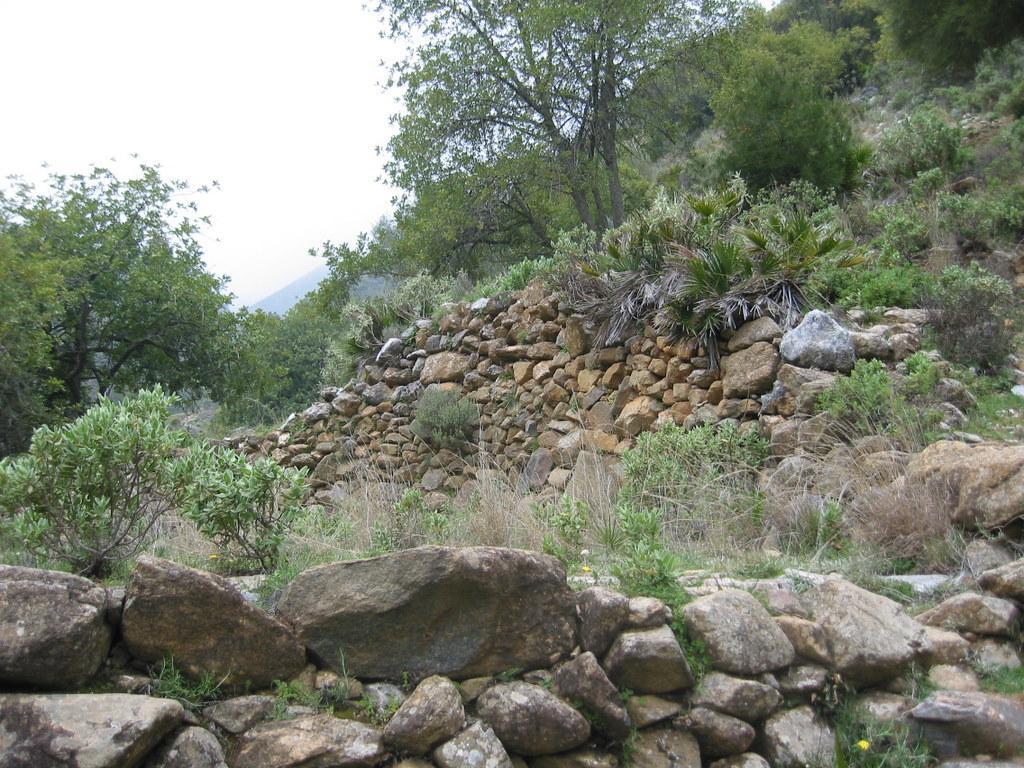Can you describe this image briefly? In this image there are stones, trees in the foreground. There are trees in the background. And there is sky at the top. 